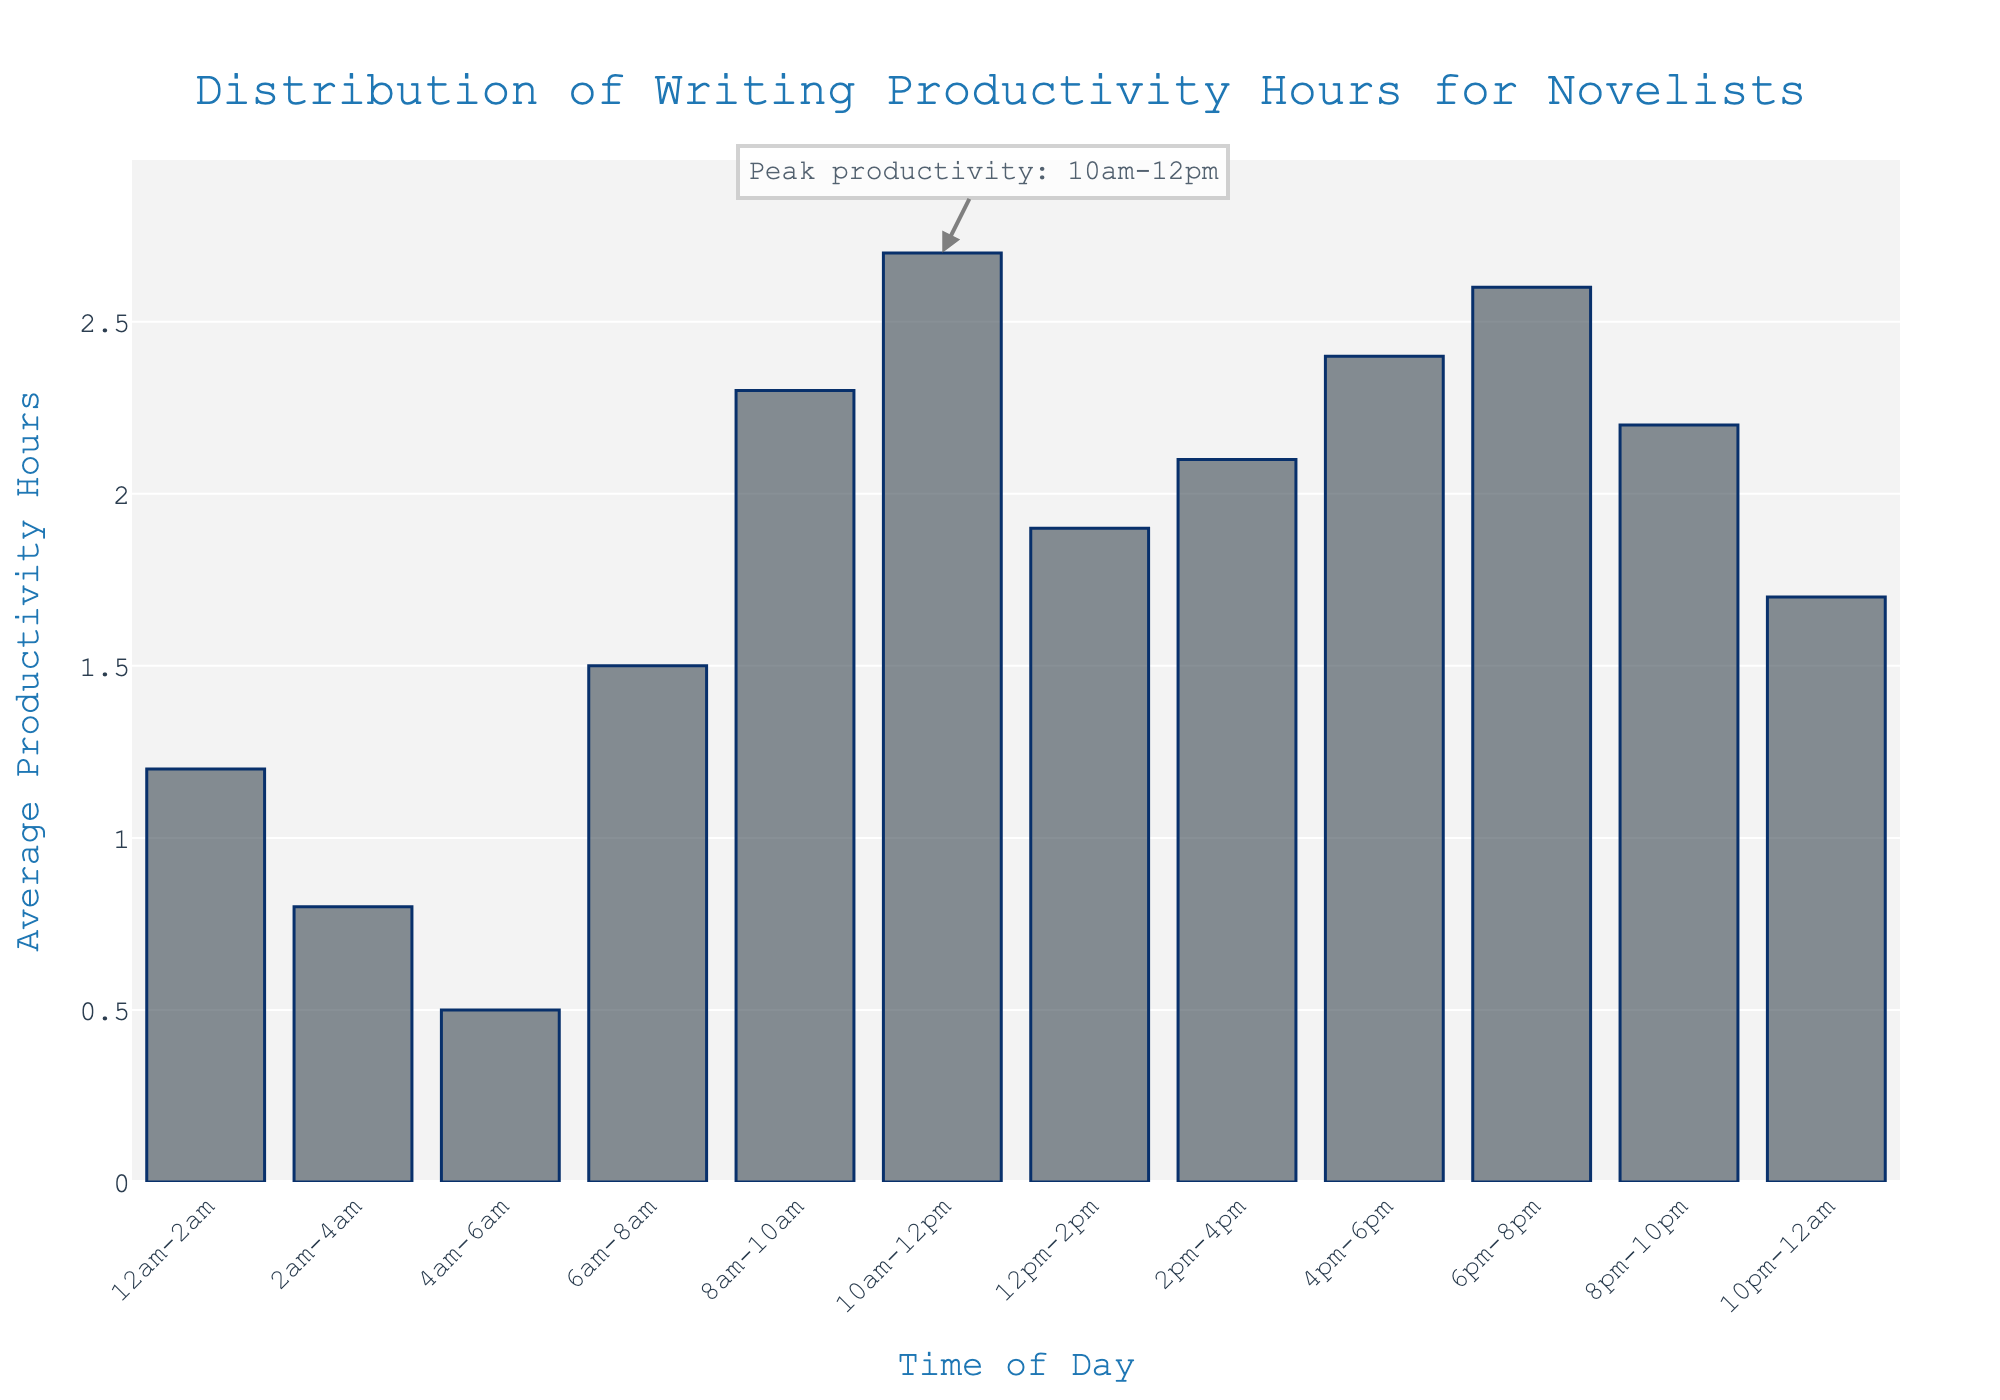What time of day has the highest average productivity hours? The bar for 10am-12pm is the tallest, indicating the highest average productivity hours.
Answer: 10am-12pm What is the difference in average productivity hours between 10am-12pm and 4pm-6pm? The average productivity for 10am-12pm is 2.7 hours, and for 4pm-6pm is 2.4 hours. The difference is 2.7 - 2.4 = 0.3 hours.
Answer: 0.3 hours Which time period has the least productivity hours? The bar for 4am-6am is the shortest, indicating it has the least productivity hours.
Answer: 4am-6am How does the average productivity change from 2am-4am to 8am-10am? The average productivity increases from 0.8 hours at 2am-4am to 2.3 hours at 8am-10am.
Answer: It increases Compare the average productivity hours for the time periods of 8am-10am and 6pm-8pm. The average productivity is 2.3 hours for 8am-10am and 2.6 hours for 6pm-8pm.
Answer: 6pm-8pm is higher Calculate the total productivity hours from 6pm-12am. Sum the average productivity hours: 6pm-8pm (2.6) + 8pm-10pm (2.2) + 10pm-12am (1.7). 2.6 + 2.2 + 1.7 = 6.5 hours.
Answer: 6.5 hours What is the average productivity during the late-night period (12am-6am)? Calculate the average productivity for 12am-2am (1.2), 2am-4am (0.8), and 4am-6am (0.5). The average is (1.2 + 0.8 + 0.5) / 3 = 2.5 / 3 = 0.83 hours.
Answer: 0.83 hours How many time periods have an average productivity of at least 2 hours? Count the bars equal to or greater than 2 hours: 8am-10am, 10am-12pm, 4pm-6pm, 6pm-8pm, and 8pm-10pm. There are 5 periods.
Answer: 5 periods What is the peak productivity time and its value? The annotated bar shows that the peak productivity is from 10am-12pm with a value of 2.7 hours.
Answer: 10am-12pm, 2.7 hours Compare the average productivity in the early morning (6am-8am) and late morning (10am-12pm). The early morning (6am-8am) has 1.5 hours, and the late morning (10am-12pm) has 2.7 hours.
Answer: Late morning is higher 